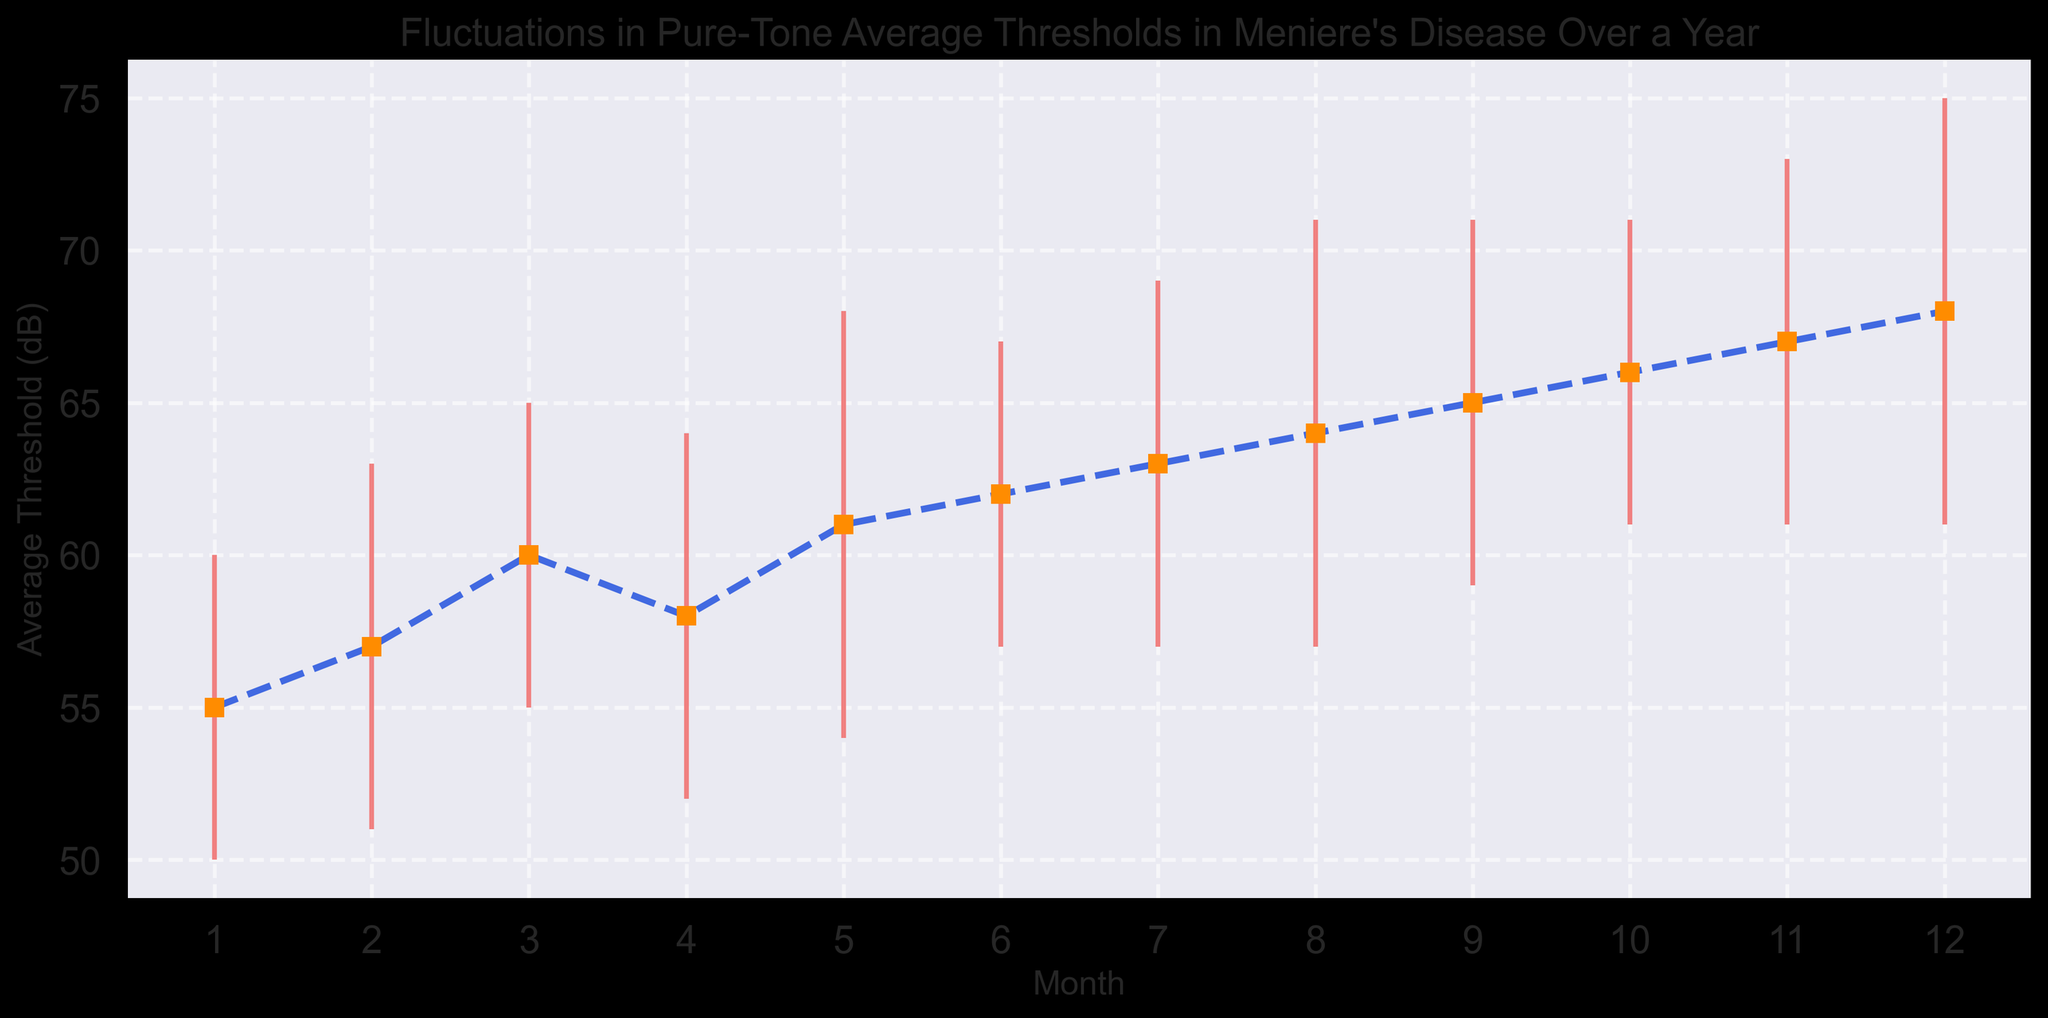Which month has the lowest average pure-tone threshold? The graph shows fluctuations in average pure-tone thresholds over the course of a year, with the lowest threshold occurring in January at 55 dB.
Answer: January Between which two consecutive months is the greatest increase in average threshold observed? To find the greatest increase, we calculate the difference between consecutive months. The largest positive difference occurs between March and April, where the average threshold increases by 6 dB (from 60 to 66 dB).
Answer: March to April What is the average pure-tone threshold in the first six months? Sum the average thresholds for the first six months (55 + 57 + 60 + 58 + 61 + 62) and divide by 6. The calculation is 353 / 6, which is approximately 58.83 dB.
Answer: 58.83 dB Which month shows the highest variation in pure-tone threshold (considering the standard deviation)? The graph includes error bars that indicate standard deviation. The highest standard deviation (7 dB) occurs in the months of May, August, and December.
Answer: May, August, December Is there a general trend observed in the average thresholds over the year? Observing the graph, the average pure-tone thresholds increase almost steadily over the year, from 55 dB in January to 68 dB in December.
Answer: Increasing trend How much does the average pure-tone threshold increase from July to December? The average threshold in July is 63 dB and in December it is 68 dB. The increase is 68 - 63 = 5 dB.
Answer: 5 dB In which months are the average pure-tone thresholds higher than 60 dB? The graph shows that the average thresholds are higher than 60 dB from May to December.
Answer: May to December Calculate the average threshold over the entire year. Sum the average thresholds for each month (55 + 57 + 60 + 58 + 61 + 62 + 63 + 64 + 65 + 66 + 67 + 68) and divide by 12. The calculation is 746 / 12, which is approximately 62.17 dB.
Answer: 62.17 dB 